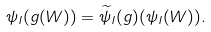Convert formula to latex. <formula><loc_0><loc_0><loc_500><loc_500>\psi _ { I } ( g ( W ) ) = \widetilde { \psi } _ { I } ( g ) ( \psi _ { I } ( W ) ) .</formula> 